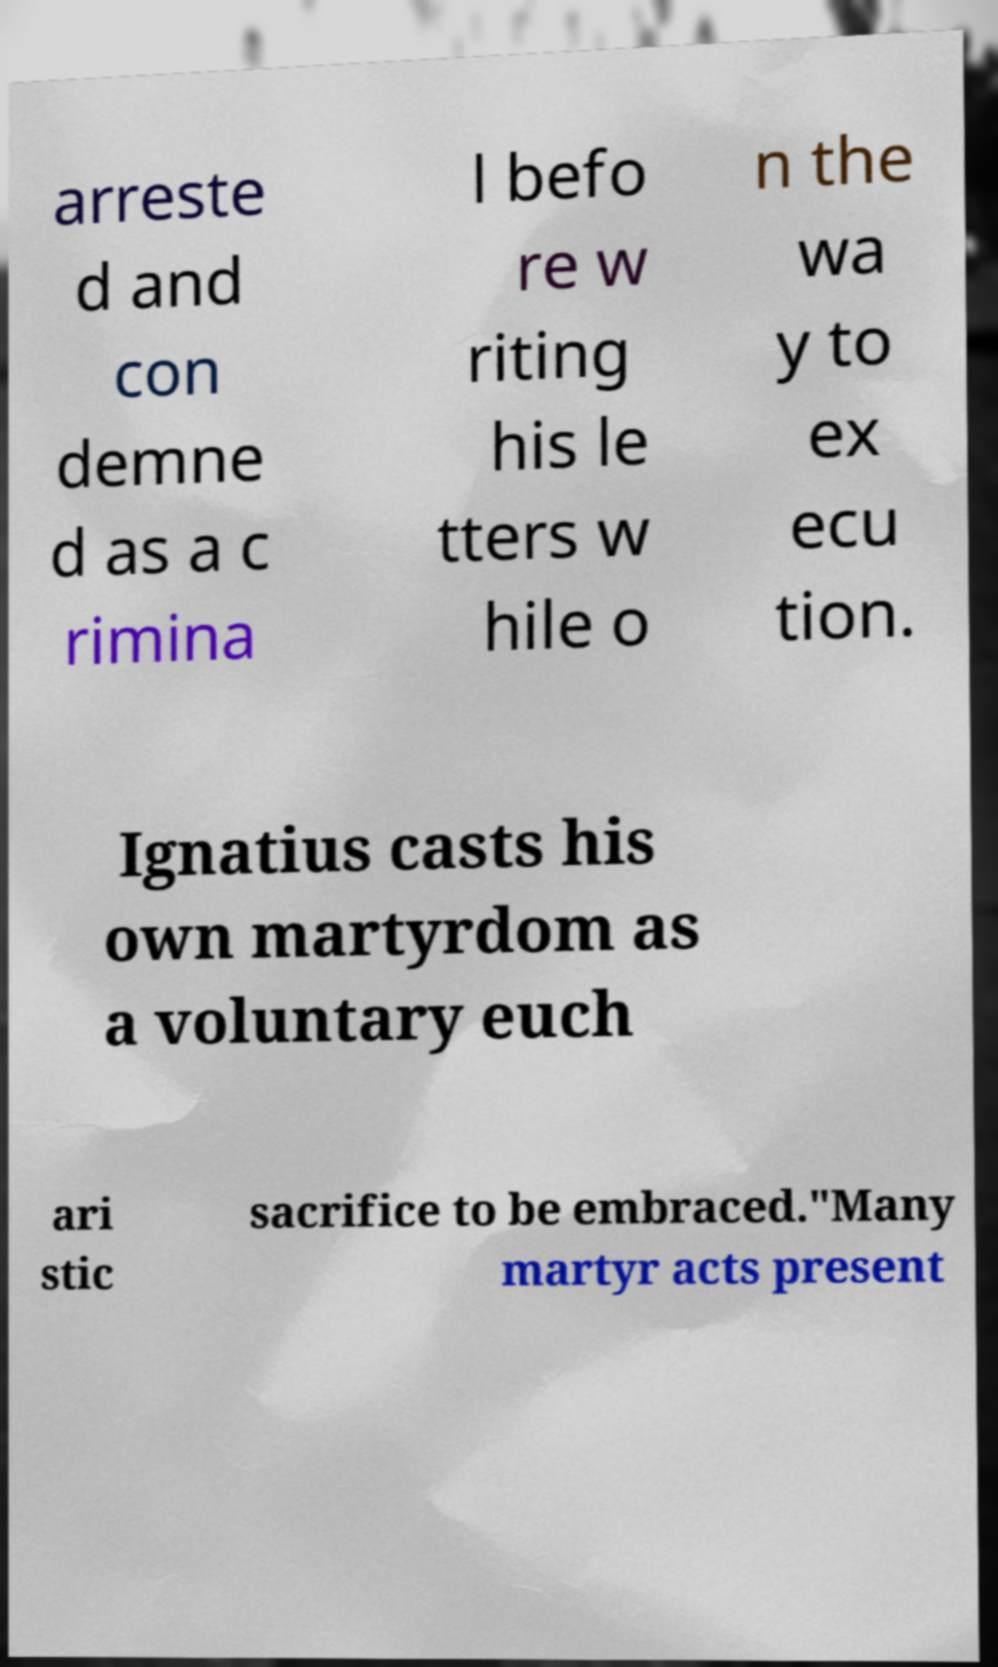There's text embedded in this image that I need extracted. Can you transcribe it verbatim? arreste d and con demne d as a c rimina l befo re w riting his le tters w hile o n the wa y to ex ecu tion. Ignatius casts his own martyrdom as a voluntary euch ari stic sacrifice to be embraced."Many martyr acts present 